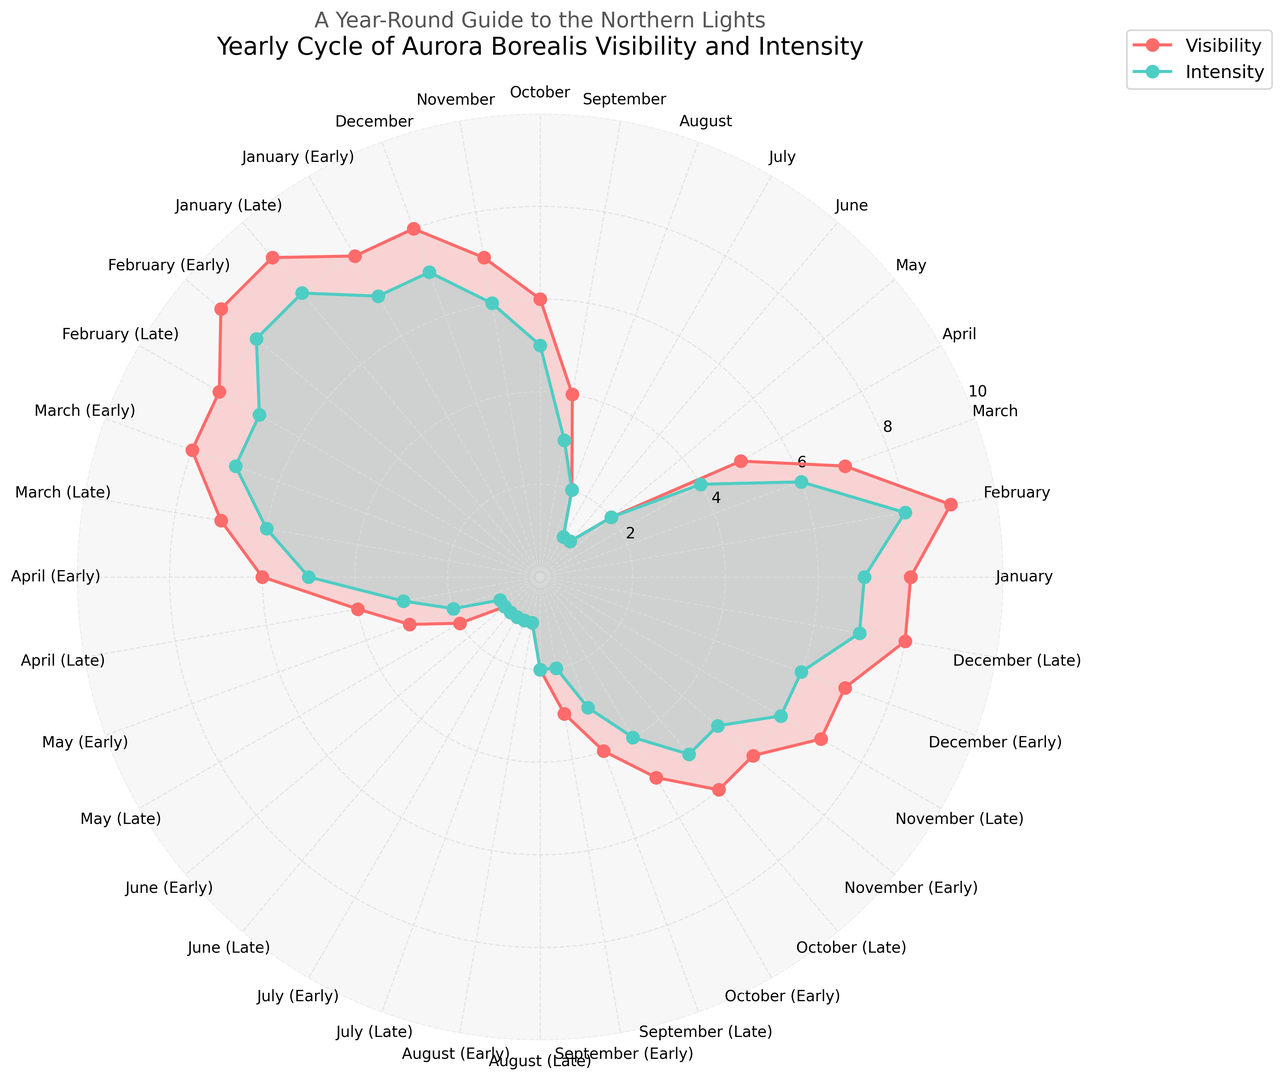What is the average visibility of the aurora borealis in January? There are three data points for January: January (8), January (Early) (8), and January (Late) (9). The average visibility is (8 + 8 + 9) / 3 = 8.33
Answer: 8.33 During which months is the visibility of the aurora borealis equal to the intensity? We need to look at the plot where the visibility and intensity lines coincide. For May, June, July, and August, both visibility and intensity have the same values.
Answer: May, June, July, August Which month shows the highest intensity and what is its value? By looking at the plot, we can see that February (Late) has the highest intensity of 8.
Answer: February (Late), 8 How does the visibility in February compare with that in March? In February, the visibility alternates between 9 and 8, averaging 8.5. In March, visibility alternates between 8 and 7, averaging 7.5. Therefore, February has higher visibility than March.
Answer: February is higher What is the difference in intensity between April (Early) and April (Late)? April (Early) has an intensity of 5, and April (Late) has an intensity of 3, so the difference is 5 - 3 = 2
Answer: 2 What is the lowest visibility recorded in any month, and which months have this visibility? The lowest visibility is 1, recorded in June (Early), June (Late), July (Early), and July (Late).
Answer: June, July During which months is the aurora borealis most visible (excluding parts of months)? January (8), February (9), and December (8) have the highest consistent visibility values throughout the entire month.
Answer: January, February, December What is the total visibility for the entire year considering each part of the months separately? Sum up each visibility value: 8 (Jan) + 8 (Jan Early) + 9 (Jan Late) + 9 (Feb) + 9 (Feb Early) + 8 (Feb Late) + 8 (Mar) + 8 (Mar Early) + 7 (Mar Late) + 6 (Apr) + 6 (Apr Early) + 4 (Apr Late) + 3 (May) + 3 (May Early) + 2 (May Late) + 1 (June) + 1 (June Early) + 1 (June Late) + 1 (July) + 1 (July Early) + 1 (July Late) + 2 (Aug) + 2 (Aug Early) + 2 (Aug Late) + 4 (Sept) + 4 (Sept Early) + 4 (Sept Late) + 6 (Oct) + 6 (Oct Early) + 6 (Oct Late) + 7 (Nov) + 7 (Nov Early) + 7 (Nov Late) + 8 (Dec) + 8 (Dec Early) + 8 (Dec Late) = 169
Answer: 169 Which months show a decrease in visibility and intensity from early to late part? March, April, and September show a decrease in both visibility and intensity from early to late parts.
Answer: March, April, September 